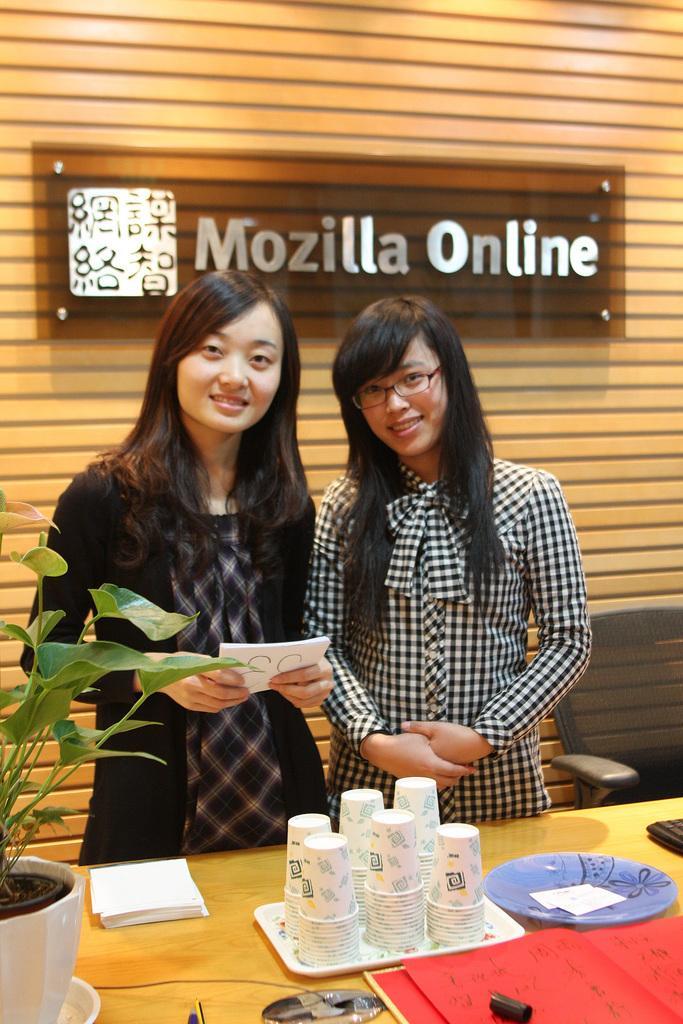Can you describe this image briefly? In the image we can see there are two women who are standing and on table there are cups, plate and in pot there is plant and the women are smiling and at the back there is a banner on which its written "Mozilla Online". 